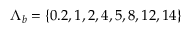<formula> <loc_0><loc_0><loc_500><loc_500>{ \Lambda } _ { b } = \{ 0 . 2 , 1 , 2 , 4 , 5 , 8 , 1 2 , 1 4 \}</formula> 